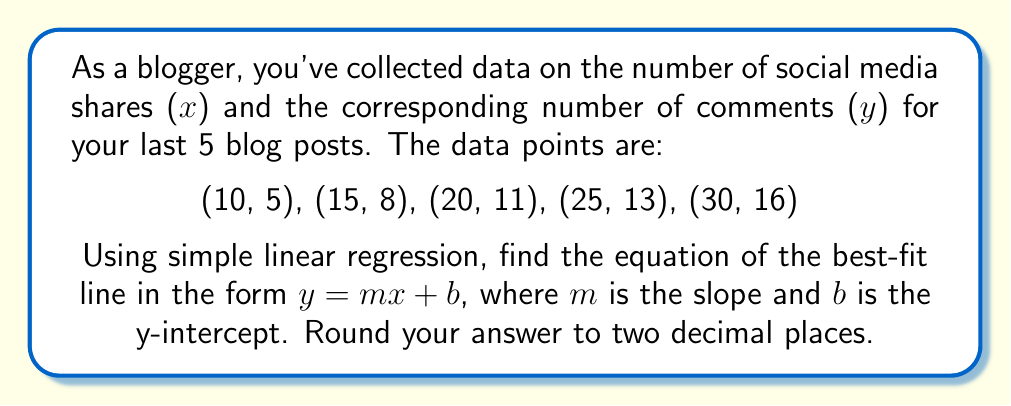Provide a solution to this math problem. To find the equation of the best-fit line using simple linear regression, we'll follow these steps:

1. Calculate the means of x and y:
   $\bar{x} = \frac{10 + 15 + 20 + 25 + 30}{5} = 20$
   $\bar{y} = \frac{5 + 8 + 11 + 13 + 16}{5} = 10.6$

2. Calculate the slope (m) using the formula:
   $$m = \frac{\sum(x_i - \bar{x})(y_i - \bar{y})}{\sum(x_i - \bar{x})^2}$$

3. Compute the numerator and denominator:
   Numerator: $(-10)(-5.6) + (-5)(-2.6) + (0)(0.4) + (5)(2.4) + (10)(5.4) = 140$
   Denominator: $(-10)^2 + (-5)^2 + (0)^2 + (5)^2 + (10)^2 = 250$

4. Calculate the slope:
   $m = \frac{140}{250} = 0.56$

5. Calculate the y-intercept (b) using the formula:
   $b = \bar{y} - m\bar{x}$
   $b = 10.6 - (0.56)(20) = -0.6$

6. Write the equation of the best-fit line:
   $y = 0.56x - 0.6$

Rounding to two decimal places: $y = 0.56x - 0.60$
Answer: $y = 0.56x - 0.60$ 